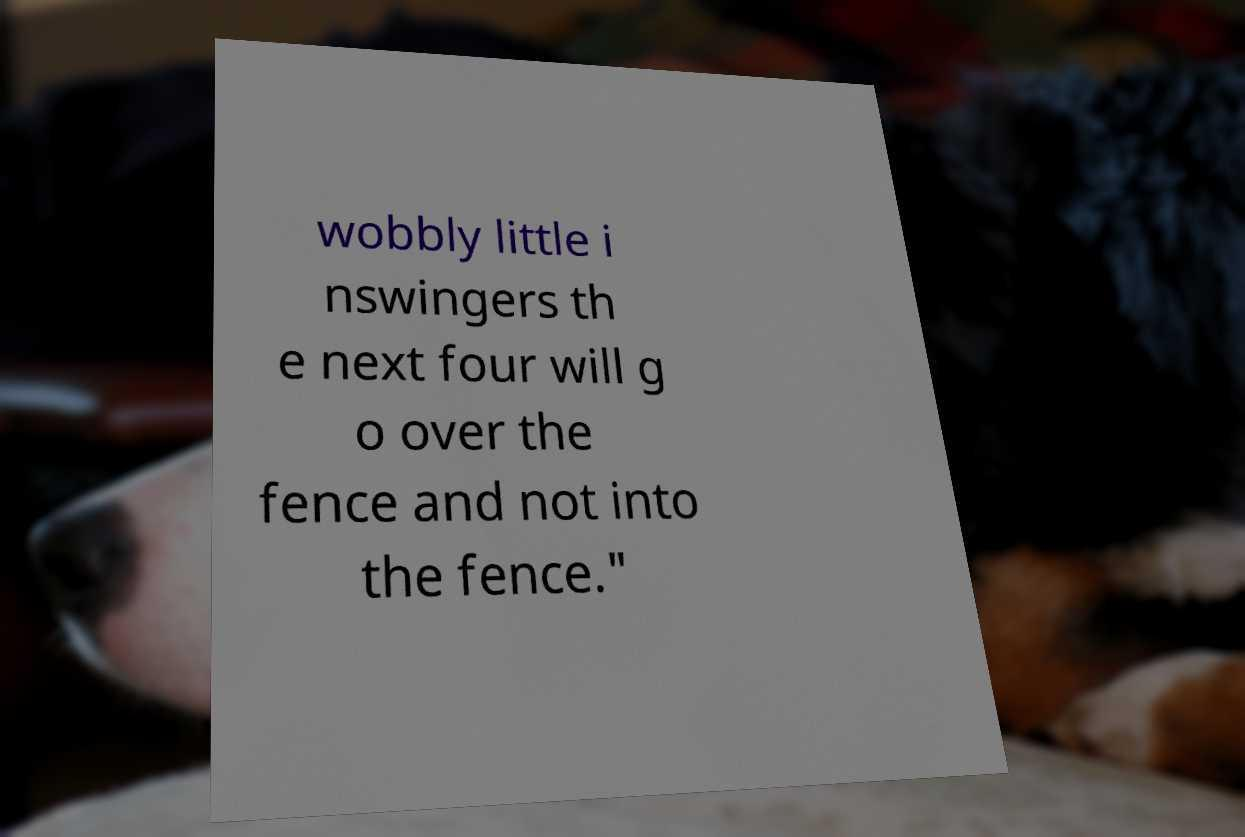For documentation purposes, I need the text within this image transcribed. Could you provide that? wobbly little i nswingers th e next four will g o over the fence and not into the fence." 